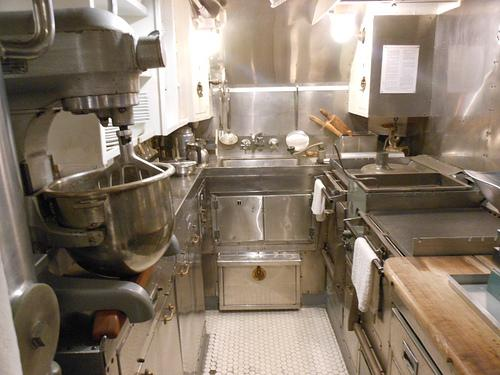Question: where are the dishes washed?
Choices:
A. Dishwasher.
B. The basin.
C. Sink.
D. The counter.
Answer with the letter. Answer: C Question: how do you wash the dishes?
Choices:
A. Water.
B. Soap.
C. Dishwasher detergent.
D. Soap and water.
Answer with the letter. Answer: D Question: where is this picture taken?
Choices:
A. Bedroom.
B. Kitchen.
C. Living room.
D. Dining room.
Answer with the letter. Answer: B Question: what color are the walls?
Choices:
A. White.
B. Silver.
C. Tan.
D. Green.
Answer with the letter. Answer: B Question: what is the floor made of?
Choices:
A. Wood.
B. Linolium.
C. Concrete.
D. Tile.
Answer with the letter. Answer: D 